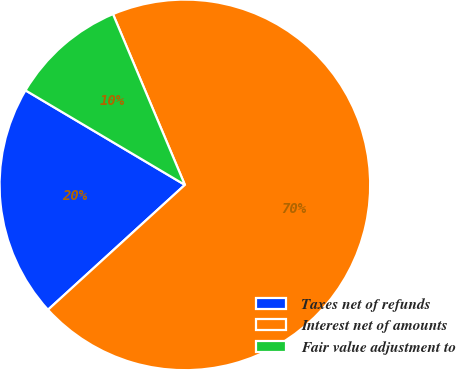Convert chart. <chart><loc_0><loc_0><loc_500><loc_500><pie_chart><fcel>Taxes net of refunds<fcel>Interest net of amounts<fcel>Fair value adjustment to<nl><fcel>20.29%<fcel>69.57%<fcel>10.14%<nl></chart> 